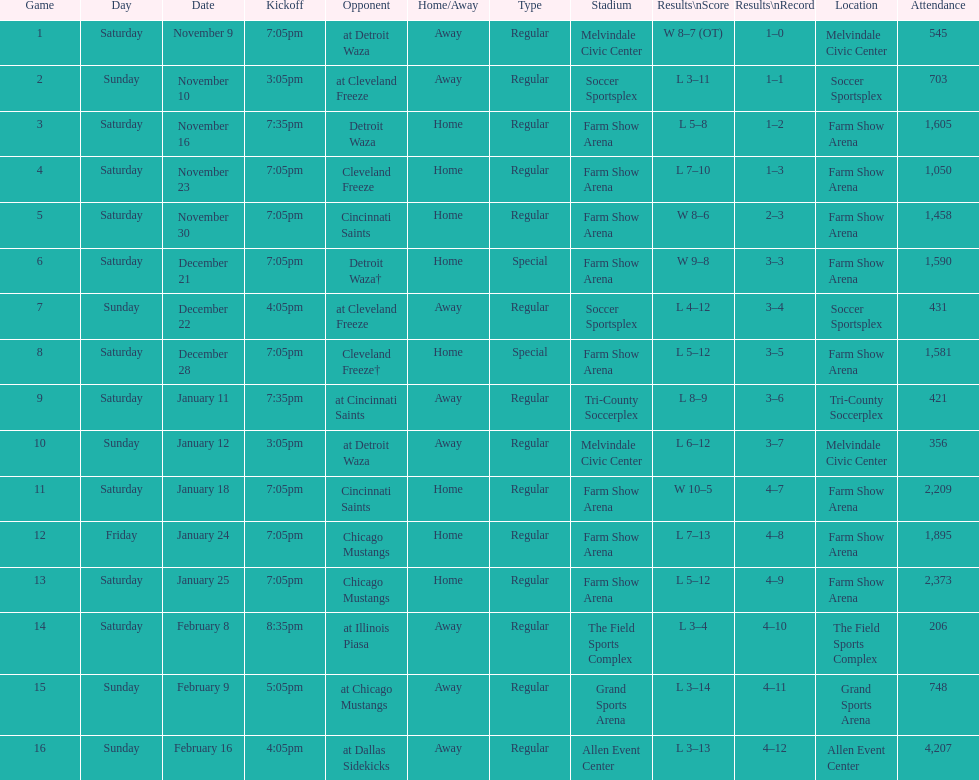How many times did the team play at home but did not win? 5. 